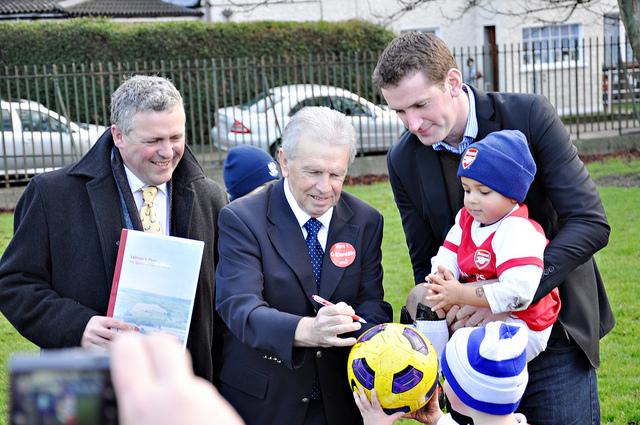What is the man signing?
Answer briefly. Soccer ball. Why does the center man have gray hair?
Be succinct. Old. Are there cars here?
Concise answer only. Yes. 